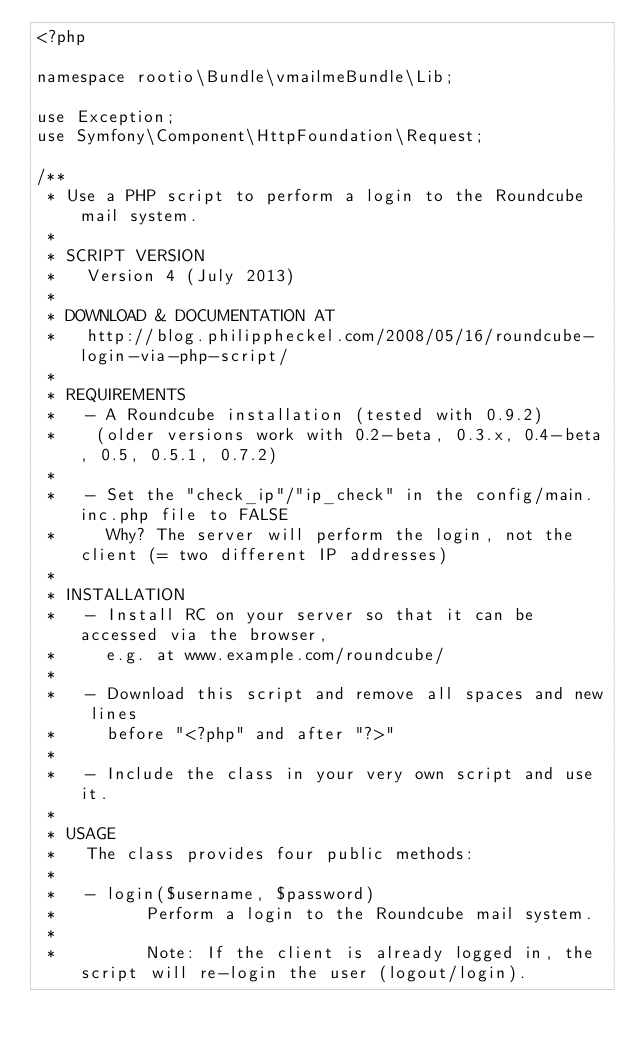Convert code to text. <code><loc_0><loc_0><loc_500><loc_500><_PHP_><?php

namespace rootio\Bundle\vmailmeBundle\Lib;

use Exception;
use Symfony\Component\HttpFoundation\Request;

/**
 * Use a PHP script to perform a login to the Roundcube mail system.
 *
 * SCRIPT VERSION
 *   Version 4 (July 2013)
 *
 * DOWNLOAD & DOCUMENTATION AT
 *   http://blog.philippheckel.com/2008/05/16/roundcube-login-via-php-script/
 *
 * REQUIREMENTS
 *   - A Roundcube installation (tested with 0.9.2)
 *    (older versions work with 0.2-beta, 0.3.x, 0.4-beta, 0.5, 0.5.1, 0.7.2)
 *
 *   - Set the "check_ip"/"ip_check" in the config/main.inc.php file to FALSE
 *     Why? The server will perform the login, not the client (= two different IP addresses)
 *
 * INSTALLATION
 *   - Install RC on your server so that it can be accessed via the browser,
 *     e.g. at www.example.com/roundcube/
 *
 *   - Download this script and remove all spaces and new lines
 *     before "<?php" and after "?>"
 *
 *   - Include the class in your very own script and use it.
 *
 * USAGE
 *   The class provides four public methods:
 *
 *   - login($username, $password)
 *         Perform a login to the Roundcube mail system.
 *
 *         Note: If the client is already logged in, the script will re-login the user (logout/login).</code> 